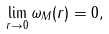Convert formula to latex. <formula><loc_0><loc_0><loc_500><loc_500>\lim _ { r \to 0 } \omega _ { M } ( r ) = 0 ,</formula> 